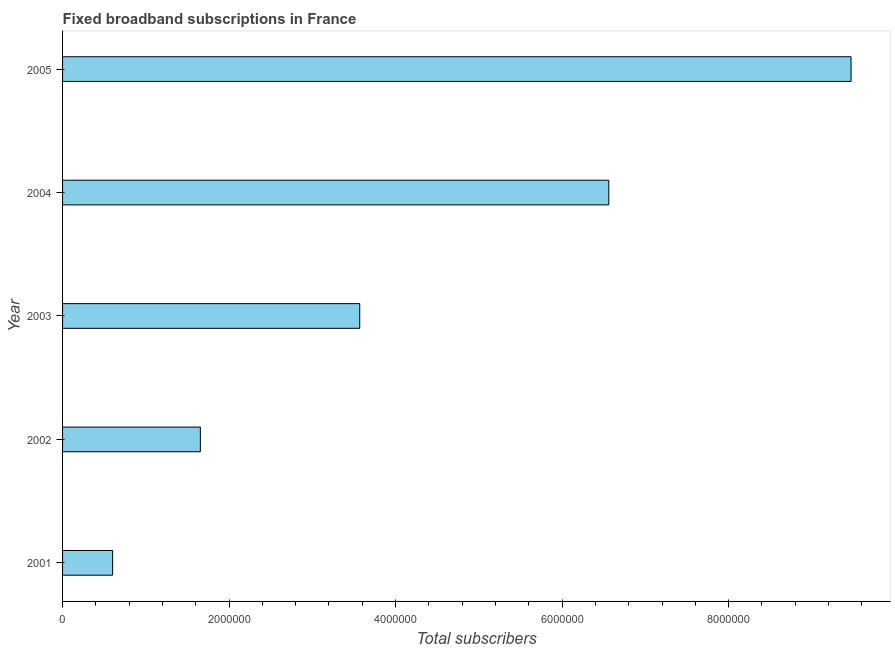What is the title of the graph?
Your answer should be very brief. Fixed broadband subscriptions in France. What is the label or title of the X-axis?
Your response must be concise. Total subscribers. What is the total number of fixed broadband subscriptions in 2001?
Ensure brevity in your answer.  6.02e+05. Across all years, what is the maximum total number of fixed broadband subscriptions?
Make the answer very short. 9.47e+06. Across all years, what is the minimum total number of fixed broadband subscriptions?
Keep it short and to the point. 6.02e+05. In which year was the total number of fixed broadband subscriptions minimum?
Keep it short and to the point. 2001. What is the sum of the total number of fixed broadband subscriptions?
Ensure brevity in your answer.  2.19e+07. What is the difference between the total number of fixed broadband subscriptions in 2001 and 2002?
Give a very brief answer. -1.05e+06. What is the average total number of fixed broadband subscriptions per year?
Your answer should be compact. 4.37e+06. What is the median total number of fixed broadband subscriptions?
Your response must be concise. 3.57e+06. In how many years, is the total number of fixed broadband subscriptions greater than 1200000 ?
Provide a succinct answer. 4. Do a majority of the years between 2002 and 2005 (inclusive) have total number of fixed broadband subscriptions greater than 4000000 ?
Your answer should be compact. No. What is the ratio of the total number of fixed broadband subscriptions in 2001 to that in 2004?
Keep it short and to the point. 0.09. What is the difference between the highest and the second highest total number of fixed broadband subscriptions?
Your answer should be very brief. 2.91e+06. Is the sum of the total number of fixed broadband subscriptions in 2004 and 2005 greater than the maximum total number of fixed broadband subscriptions across all years?
Give a very brief answer. Yes. What is the difference between the highest and the lowest total number of fixed broadband subscriptions?
Keep it short and to the point. 8.87e+06. Are all the bars in the graph horizontal?
Give a very brief answer. Yes. What is the difference between two consecutive major ticks on the X-axis?
Give a very brief answer. 2.00e+06. What is the Total subscribers of 2001?
Your response must be concise. 6.02e+05. What is the Total subscribers in 2002?
Give a very brief answer. 1.66e+06. What is the Total subscribers in 2003?
Your answer should be very brief. 3.57e+06. What is the Total subscribers in 2004?
Offer a terse response. 6.56e+06. What is the Total subscribers of 2005?
Ensure brevity in your answer.  9.47e+06. What is the difference between the Total subscribers in 2001 and 2002?
Provide a succinct answer. -1.05e+06. What is the difference between the Total subscribers in 2001 and 2003?
Your response must be concise. -2.97e+06. What is the difference between the Total subscribers in 2001 and 2004?
Give a very brief answer. -5.96e+06. What is the difference between the Total subscribers in 2001 and 2005?
Your answer should be compact. -8.87e+06. What is the difference between the Total subscribers in 2002 and 2003?
Provide a succinct answer. -1.91e+06. What is the difference between the Total subscribers in 2002 and 2004?
Offer a very short reply. -4.91e+06. What is the difference between the Total subscribers in 2002 and 2005?
Offer a very short reply. -7.82e+06. What is the difference between the Total subscribers in 2003 and 2004?
Provide a succinct answer. -2.99e+06. What is the difference between the Total subscribers in 2003 and 2005?
Make the answer very short. -5.90e+06. What is the difference between the Total subscribers in 2004 and 2005?
Provide a short and direct response. -2.91e+06. What is the ratio of the Total subscribers in 2001 to that in 2002?
Your answer should be very brief. 0.36. What is the ratio of the Total subscribers in 2001 to that in 2003?
Give a very brief answer. 0.17. What is the ratio of the Total subscribers in 2001 to that in 2004?
Your answer should be very brief. 0.09. What is the ratio of the Total subscribers in 2001 to that in 2005?
Give a very brief answer. 0.06. What is the ratio of the Total subscribers in 2002 to that in 2003?
Your response must be concise. 0.46. What is the ratio of the Total subscribers in 2002 to that in 2004?
Make the answer very short. 0.25. What is the ratio of the Total subscribers in 2002 to that in 2005?
Provide a short and direct response. 0.17. What is the ratio of the Total subscribers in 2003 to that in 2004?
Your answer should be very brief. 0.54. What is the ratio of the Total subscribers in 2003 to that in 2005?
Ensure brevity in your answer.  0.38. What is the ratio of the Total subscribers in 2004 to that in 2005?
Your answer should be compact. 0.69. 